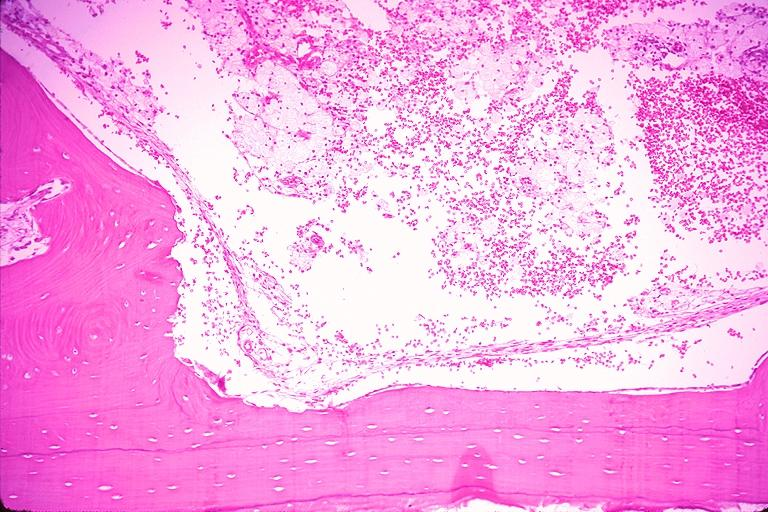where is this?
Answer the question using a single word or phrase. Oral 